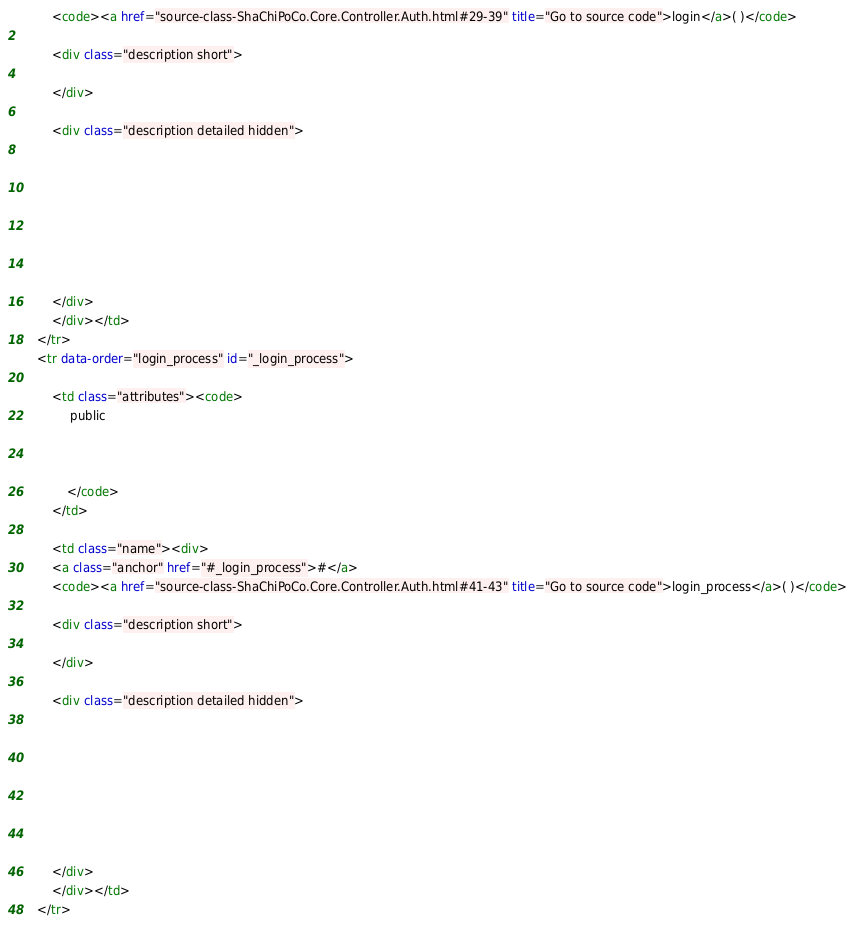<code> <loc_0><loc_0><loc_500><loc_500><_HTML_>		<code><a href="source-class-ShaChiPoCo.Core.Controller.Auth.html#29-39" title="Go to source code">login</a>( )</code>

		<div class="description short">
			
		</div>

		<div class="description detailed hidden">
			







		</div>
		</div></td>
	</tr>
	<tr data-order="login_process" id="_login_process">

		<td class="attributes"><code>
			 public 

			
			
			</code>
		</td>

		<td class="name"><div>
		<a class="anchor" href="#_login_process">#</a>
		<code><a href="source-class-ShaChiPoCo.Core.Controller.Auth.html#41-43" title="Go to source code">login_process</a>( )</code>

		<div class="description short">
			
		</div>

		<div class="description detailed hidden">
			







		</div>
		</div></td>
	</tr></code> 